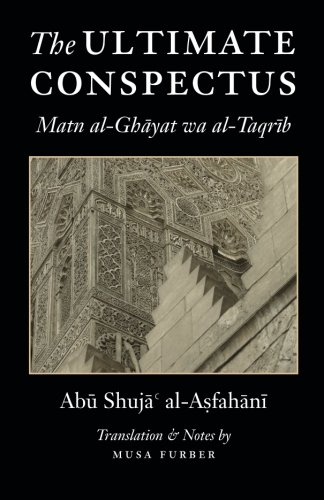Who wrote this book?
Answer the question using a single word or phrase. Abu Shuja' al-Asfahani What is the title of this book? The Ultimate Conspectus: Matn al-Ghayat wa al-Taqrib What type of book is this? Religion & Spirituality Is this book related to Religion & Spirituality? Yes Is this book related to Reference? No 